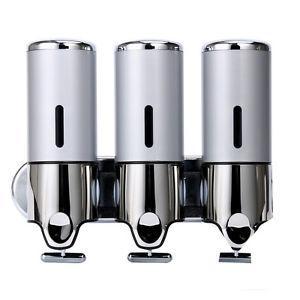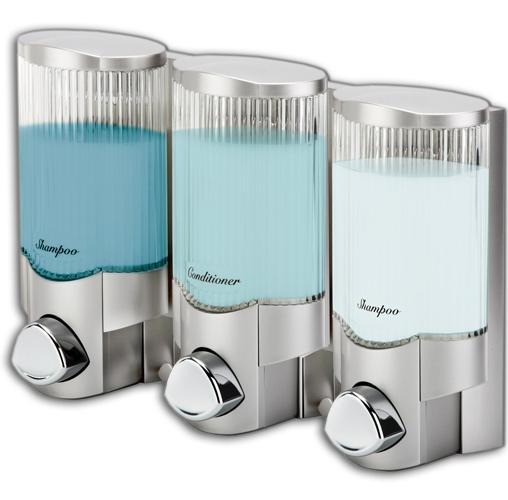The first image is the image on the left, the second image is the image on the right. Given the left and right images, does the statement "At least one image contains three dispensers which are all not transparent." hold true? Answer yes or no. Yes. The first image is the image on the left, the second image is the image on the right. For the images shown, is this caption "There are three dispensers in which the top half is fully silver with only one line of an open window to see liquid." true? Answer yes or no. Yes. 